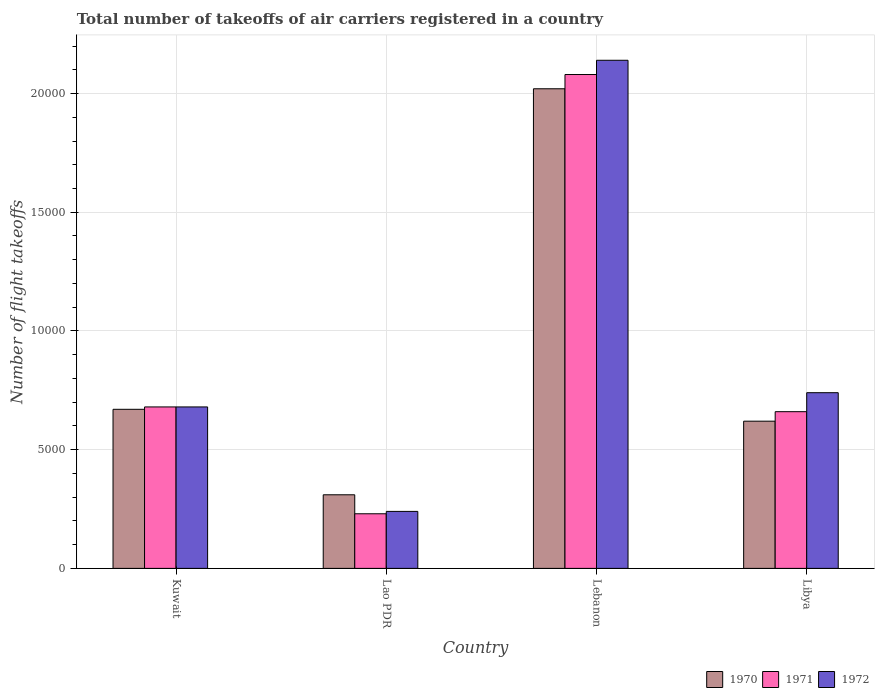How many different coloured bars are there?
Your response must be concise. 3. How many groups of bars are there?
Make the answer very short. 4. Are the number of bars per tick equal to the number of legend labels?
Your answer should be very brief. Yes. How many bars are there on the 3rd tick from the left?
Give a very brief answer. 3. What is the label of the 4th group of bars from the left?
Give a very brief answer. Libya. What is the total number of flight takeoffs in 1971 in Lebanon?
Keep it short and to the point. 2.08e+04. Across all countries, what is the maximum total number of flight takeoffs in 1972?
Keep it short and to the point. 2.14e+04. Across all countries, what is the minimum total number of flight takeoffs in 1970?
Offer a terse response. 3100. In which country was the total number of flight takeoffs in 1970 maximum?
Keep it short and to the point. Lebanon. In which country was the total number of flight takeoffs in 1971 minimum?
Ensure brevity in your answer.  Lao PDR. What is the total total number of flight takeoffs in 1970 in the graph?
Offer a terse response. 3.62e+04. What is the difference between the total number of flight takeoffs in 1971 in Lao PDR and the total number of flight takeoffs in 1972 in Libya?
Provide a succinct answer. -5100. What is the average total number of flight takeoffs in 1972 per country?
Make the answer very short. 9500. What is the difference between the total number of flight takeoffs of/in 1971 and total number of flight takeoffs of/in 1972 in Lebanon?
Your answer should be compact. -600. What is the ratio of the total number of flight takeoffs in 1970 in Kuwait to that in Libya?
Your response must be concise. 1.08. Is the total number of flight takeoffs in 1972 in Lao PDR less than that in Lebanon?
Make the answer very short. Yes. What is the difference between the highest and the second highest total number of flight takeoffs in 1971?
Ensure brevity in your answer.  1.40e+04. What is the difference between the highest and the lowest total number of flight takeoffs in 1970?
Make the answer very short. 1.71e+04. In how many countries, is the total number of flight takeoffs in 1971 greater than the average total number of flight takeoffs in 1971 taken over all countries?
Provide a succinct answer. 1. Is the sum of the total number of flight takeoffs in 1970 in Lao PDR and Lebanon greater than the maximum total number of flight takeoffs in 1972 across all countries?
Offer a terse response. Yes. How many bars are there?
Keep it short and to the point. 12. What is the difference between two consecutive major ticks on the Y-axis?
Your response must be concise. 5000. Does the graph contain any zero values?
Give a very brief answer. No. Does the graph contain grids?
Your answer should be very brief. Yes. How many legend labels are there?
Provide a succinct answer. 3. How are the legend labels stacked?
Your answer should be compact. Horizontal. What is the title of the graph?
Your answer should be compact. Total number of takeoffs of air carriers registered in a country. What is the label or title of the X-axis?
Make the answer very short. Country. What is the label or title of the Y-axis?
Give a very brief answer. Number of flight takeoffs. What is the Number of flight takeoffs in 1970 in Kuwait?
Provide a succinct answer. 6700. What is the Number of flight takeoffs of 1971 in Kuwait?
Keep it short and to the point. 6800. What is the Number of flight takeoffs in 1972 in Kuwait?
Ensure brevity in your answer.  6800. What is the Number of flight takeoffs of 1970 in Lao PDR?
Your response must be concise. 3100. What is the Number of flight takeoffs of 1971 in Lao PDR?
Ensure brevity in your answer.  2300. What is the Number of flight takeoffs of 1972 in Lao PDR?
Offer a very short reply. 2400. What is the Number of flight takeoffs of 1970 in Lebanon?
Provide a short and direct response. 2.02e+04. What is the Number of flight takeoffs of 1971 in Lebanon?
Offer a terse response. 2.08e+04. What is the Number of flight takeoffs of 1972 in Lebanon?
Provide a succinct answer. 2.14e+04. What is the Number of flight takeoffs of 1970 in Libya?
Your response must be concise. 6200. What is the Number of flight takeoffs in 1971 in Libya?
Your answer should be very brief. 6600. What is the Number of flight takeoffs of 1972 in Libya?
Ensure brevity in your answer.  7400. Across all countries, what is the maximum Number of flight takeoffs of 1970?
Your response must be concise. 2.02e+04. Across all countries, what is the maximum Number of flight takeoffs of 1971?
Ensure brevity in your answer.  2.08e+04. Across all countries, what is the maximum Number of flight takeoffs in 1972?
Your answer should be compact. 2.14e+04. Across all countries, what is the minimum Number of flight takeoffs in 1970?
Provide a succinct answer. 3100. Across all countries, what is the minimum Number of flight takeoffs in 1971?
Make the answer very short. 2300. Across all countries, what is the minimum Number of flight takeoffs of 1972?
Your answer should be very brief. 2400. What is the total Number of flight takeoffs in 1970 in the graph?
Ensure brevity in your answer.  3.62e+04. What is the total Number of flight takeoffs in 1971 in the graph?
Keep it short and to the point. 3.65e+04. What is the total Number of flight takeoffs in 1972 in the graph?
Your answer should be compact. 3.80e+04. What is the difference between the Number of flight takeoffs of 1970 in Kuwait and that in Lao PDR?
Keep it short and to the point. 3600. What is the difference between the Number of flight takeoffs of 1971 in Kuwait and that in Lao PDR?
Make the answer very short. 4500. What is the difference between the Number of flight takeoffs of 1972 in Kuwait and that in Lao PDR?
Provide a short and direct response. 4400. What is the difference between the Number of flight takeoffs in 1970 in Kuwait and that in Lebanon?
Your answer should be very brief. -1.35e+04. What is the difference between the Number of flight takeoffs of 1971 in Kuwait and that in Lebanon?
Provide a short and direct response. -1.40e+04. What is the difference between the Number of flight takeoffs in 1972 in Kuwait and that in Lebanon?
Offer a very short reply. -1.46e+04. What is the difference between the Number of flight takeoffs in 1970 in Kuwait and that in Libya?
Ensure brevity in your answer.  500. What is the difference between the Number of flight takeoffs in 1972 in Kuwait and that in Libya?
Ensure brevity in your answer.  -600. What is the difference between the Number of flight takeoffs in 1970 in Lao PDR and that in Lebanon?
Your answer should be very brief. -1.71e+04. What is the difference between the Number of flight takeoffs in 1971 in Lao PDR and that in Lebanon?
Provide a short and direct response. -1.85e+04. What is the difference between the Number of flight takeoffs in 1972 in Lao PDR and that in Lebanon?
Keep it short and to the point. -1.90e+04. What is the difference between the Number of flight takeoffs in 1970 in Lao PDR and that in Libya?
Offer a very short reply. -3100. What is the difference between the Number of flight takeoffs in 1971 in Lao PDR and that in Libya?
Give a very brief answer. -4300. What is the difference between the Number of flight takeoffs of 1972 in Lao PDR and that in Libya?
Your answer should be compact. -5000. What is the difference between the Number of flight takeoffs of 1970 in Lebanon and that in Libya?
Offer a very short reply. 1.40e+04. What is the difference between the Number of flight takeoffs of 1971 in Lebanon and that in Libya?
Provide a short and direct response. 1.42e+04. What is the difference between the Number of flight takeoffs in 1972 in Lebanon and that in Libya?
Keep it short and to the point. 1.40e+04. What is the difference between the Number of flight takeoffs in 1970 in Kuwait and the Number of flight takeoffs in 1971 in Lao PDR?
Provide a short and direct response. 4400. What is the difference between the Number of flight takeoffs of 1970 in Kuwait and the Number of flight takeoffs of 1972 in Lao PDR?
Provide a succinct answer. 4300. What is the difference between the Number of flight takeoffs of 1971 in Kuwait and the Number of flight takeoffs of 1972 in Lao PDR?
Ensure brevity in your answer.  4400. What is the difference between the Number of flight takeoffs of 1970 in Kuwait and the Number of flight takeoffs of 1971 in Lebanon?
Provide a succinct answer. -1.41e+04. What is the difference between the Number of flight takeoffs in 1970 in Kuwait and the Number of flight takeoffs in 1972 in Lebanon?
Provide a short and direct response. -1.47e+04. What is the difference between the Number of flight takeoffs in 1971 in Kuwait and the Number of flight takeoffs in 1972 in Lebanon?
Offer a terse response. -1.46e+04. What is the difference between the Number of flight takeoffs in 1970 in Kuwait and the Number of flight takeoffs in 1972 in Libya?
Your response must be concise. -700. What is the difference between the Number of flight takeoffs of 1971 in Kuwait and the Number of flight takeoffs of 1972 in Libya?
Offer a terse response. -600. What is the difference between the Number of flight takeoffs of 1970 in Lao PDR and the Number of flight takeoffs of 1971 in Lebanon?
Keep it short and to the point. -1.77e+04. What is the difference between the Number of flight takeoffs of 1970 in Lao PDR and the Number of flight takeoffs of 1972 in Lebanon?
Provide a succinct answer. -1.83e+04. What is the difference between the Number of flight takeoffs of 1971 in Lao PDR and the Number of flight takeoffs of 1972 in Lebanon?
Keep it short and to the point. -1.91e+04. What is the difference between the Number of flight takeoffs of 1970 in Lao PDR and the Number of flight takeoffs of 1971 in Libya?
Offer a terse response. -3500. What is the difference between the Number of flight takeoffs of 1970 in Lao PDR and the Number of flight takeoffs of 1972 in Libya?
Your answer should be compact. -4300. What is the difference between the Number of flight takeoffs in 1971 in Lao PDR and the Number of flight takeoffs in 1972 in Libya?
Give a very brief answer. -5100. What is the difference between the Number of flight takeoffs of 1970 in Lebanon and the Number of flight takeoffs of 1971 in Libya?
Keep it short and to the point. 1.36e+04. What is the difference between the Number of flight takeoffs in 1970 in Lebanon and the Number of flight takeoffs in 1972 in Libya?
Give a very brief answer. 1.28e+04. What is the difference between the Number of flight takeoffs of 1971 in Lebanon and the Number of flight takeoffs of 1972 in Libya?
Provide a short and direct response. 1.34e+04. What is the average Number of flight takeoffs in 1970 per country?
Offer a very short reply. 9050. What is the average Number of flight takeoffs of 1971 per country?
Offer a very short reply. 9125. What is the average Number of flight takeoffs in 1972 per country?
Give a very brief answer. 9500. What is the difference between the Number of flight takeoffs in 1970 and Number of flight takeoffs in 1971 in Kuwait?
Make the answer very short. -100. What is the difference between the Number of flight takeoffs of 1970 and Number of flight takeoffs of 1972 in Kuwait?
Give a very brief answer. -100. What is the difference between the Number of flight takeoffs of 1971 and Number of flight takeoffs of 1972 in Kuwait?
Your response must be concise. 0. What is the difference between the Number of flight takeoffs in 1970 and Number of flight takeoffs in 1971 in Lao PDR?
Offer a terse response. 800. What is the difference between the Number of flight takeoffs of 1970 and Number of flight takeoffs of 1972 in Lao PDR?
Give a very brief answer. 700. What is the difference between the Number of flight takeoffs of 1971 and Number of flight takeoffs of 1972 in Lao PDR?
Ensure brevity in your answer.  -100. What is the difference between the Number of flight takeoffs of 1970 and Number of flight takeoffs of 1971 in Lebanon?
Provide a succinct answer. -600. What is the difference between the Number of flight takeoffs in 1970 and Number of flight takeoffs in 1972 in Lebanon?
Give a very brief answer. -1200. What is the difference between the Number of flight takeoffs of 1971 and Number of flight takeoffs of 1972 in Lebanon?
Offer a terse response. -600. What is the difference between the Number of flight takeoffs of 1970 and Number of flight takeoffs of 1971 in Libya?
Provide a succinct answer. -400. What is the difference between the Number of flight takeoffs of 1970 and Number of flight takeoffs of 1972 in Libya?
Your answer should be very brief. -1200. What is the difference between the Number of flight takeoffs in 1971 and Number of flight takeoffs in 1972 in Libya?
Give a very brief answer. -800. What is the ratio of the Number of flight takeoffs in 1970 in Kuwait to that in Lao PDR?
Your answer should be compact. 2.16. What is the ratio of the Number of flight takeoffs of 1971 in Kuwait to that in Lao PDR?
Give a very brief answer. 2.96. What is the ratio of the Number of flight takeoffs of 1972 in Kuwait to that in Lao PDR?
Give a very brief answer. 2.83. What is the ratio of the Number of flight takeoffs of 1970 in Kuwait to that in Lebanon?
Provide a succinct answer. 0.33. What is the ratio of the Number of flight takeoffs of 1971 in Kuwait to that in Lebanon?
Your answer should be compact. 0.33. What is the ratio of the Number of flight takeoffs in 1972 in Kuwait to that in Lebanon?
Give a very brief answer. 0.32. What is the ratio of the Number of flight takeoffs of 1970 in Kuwait to that in Libya?
Your response must be concise. 1.08. What is the ratio of the Number of flight takeoffs of 1971 in Kuwait to that in Libya?
Provide a succinct answer. 1.03. What is the ratio of the Number of flight takeoffs in 1972 in Kuwait to that in Libya?
Provide a succinct answer. 0.92. What is the ratio of the Number of flight takeoffs in 1970 in Lao PDR to that in Lebanon?
Provide a short and direct response. 0.15. What is the ratio of the Number of flight takeoffs in 1971 in Lao PDR to that in Lebanon?
Provide a succinct answer. 0.11. What is the ratio of the Number of flight takeoffs in 1972 in Lao PDR to that in Lebanon?
Make the answer very short. 0.11. What is the ratio of the Number of flight takeoffs of 1970 in Lao PDR to that in Libya?
Provide a succinct answer. 0.5. What is the ratio of the Number of flight takeoffs in 1971 in Lao PDR to that in Libya?
Provide a short and direct response. 0.35. What is the ratio of the Number of flight takeoffs in 1972 in Lao PDR to that in Libya?
Ensure brevity in your answer.  0.32. What is the ratio of the Number of flight takeoffs in 1970 in Lebanon to that in Libya?
Your answer should be compact. 3.26. What is the ratio of the Number of flight takeoffs in 1971 in Lebanon to that in Libya?
Your answer should be very brief. 3.15. What is the ratio of the Number of flight takeoffs in 1972 in Lebanon to that in Libya?
Provide a succinct answer. 2.89. What is the difference between the highest and the second highest Number of flight takeoffs in 1970?
Offer a terse response. 1.35e+04. What is the difference between the highest and the second highest Number of flight takeoffs of 1971?
Offer a very short reply. 1.40e+04. What is the difference between the highest and the second highest Number of flight takeoffs in 1972?
Offer a very short reply. 1.40e+04. What is the difference between the highest and the lowest Number of flight takeoffs of 1970?
Give a very brief answer. 1.71e+04. What is the difference between the highest and the lowest Number of flight takeoffs of 1971?
Provide a succinct answer. 1.85e+04. What is the difference between the highest and the lowest Number of flight takeoffs of 1972?
Provide a succinct answer. 1.90e+04. 